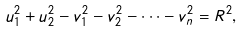Convert formula to latex. <formula><loc_0><loc_0><loc_500><loc_500>u _ { 1 } ^ { 2 } + u _ { 2 } ^ { 2 } - v _ { 1 } ^ { 2 } - v _ { 2 } ^ { 2 } - \dots - v _ { n } ^ { 2 } = R ^ { 2 } ,</formula> 